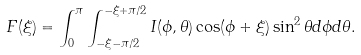Convert formula to latex. <formula><loc_0><loc_0><loc_500><loc_500>F ( \xi ) = \int _ { 0 } ^ { \pi } \int _ { - \xi - \pi / 2 } ^ { - \xi + \pi / 2 } I ( \phi , \theta ) \cos ( \phi + \xi ) \sin ^ { 2 } \theta d \phi d \theta .</formula> 